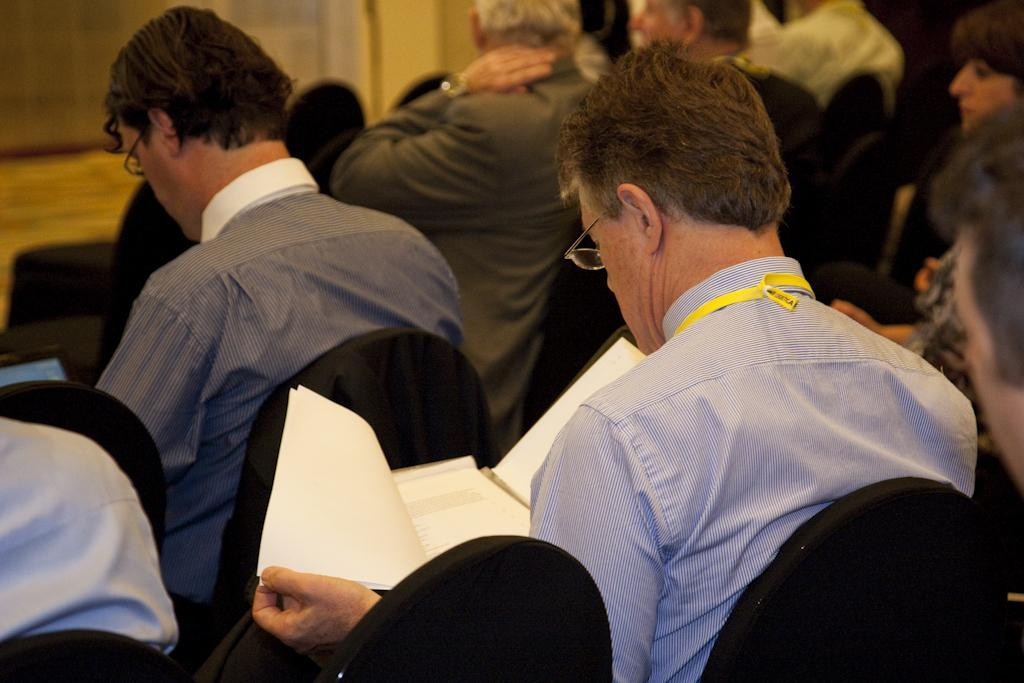What is the main subject of the image? The main subject of the image is a group of people. What are the people doing in the image? The people are sitting on chairs in the image. What are the people holding in the image? The people are holding objects in the image. What can be seen on the faces of the people in the image? The people are wearing spectacles in the image. What type of leaf can be seen falling in the image? There is no leaf present in the image; it features a group of people sitting on chairs and holding objects. What sound can be heard coming from the people in the image? The image is a still image, so no sound can be heard. 